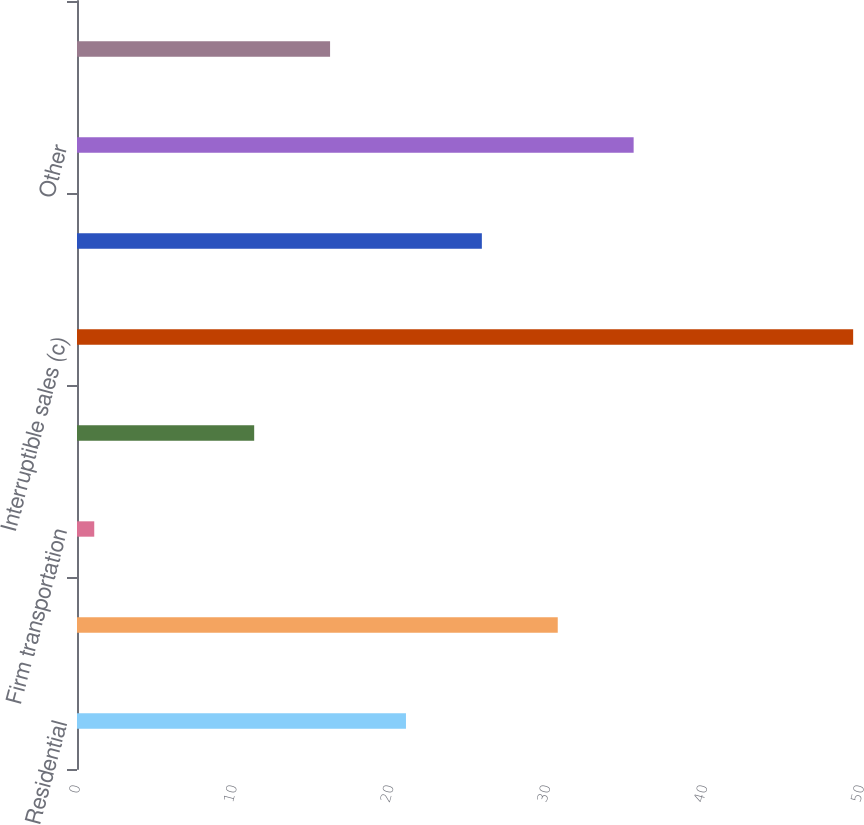Convert chart to OTSL. <chart><loc_0><loc_0><loc_500><loc_500><bar_chart><fcel>Residential<fcel>General<fcel>Firm transportation<fcel>Total firm sales and<fcel>Interruptible sales (c)<fcel>Generation plants<fcel>Other<fcel>Total<nl><fcel>20.98<fcel>30.66<fcel>1.1<fcel>11.3<fcel>49.5<fcel>25.82<fcel>35.5<fcel>16.14<nl></chart> 